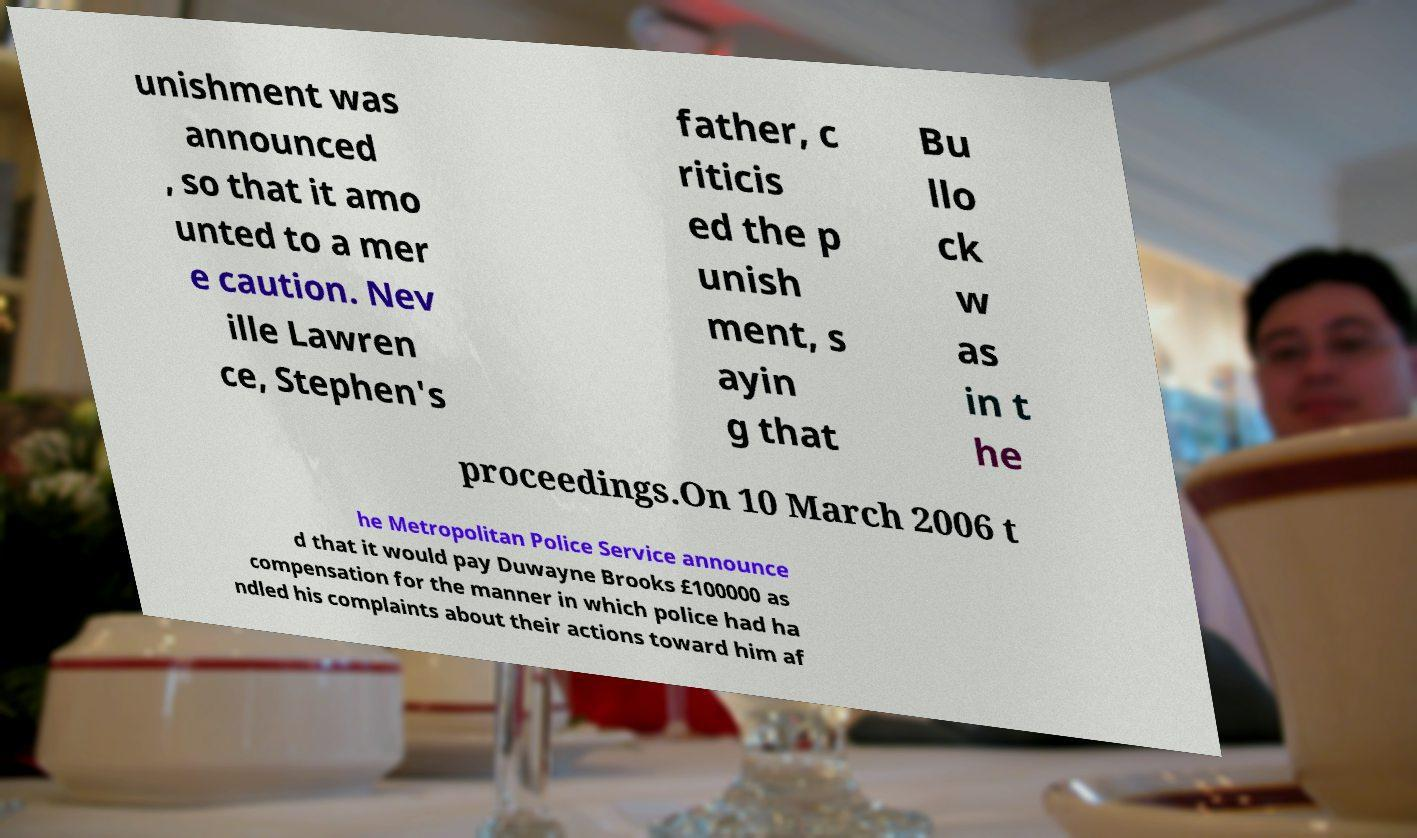For documentation purposes, I need the text within this image transcribed. Could you provide that? unishment was announced , so that it amo unted to a mer e caution. Nev ille Lawren ce, Stephen's father, c riticis ed the p unish ment, s ayin g that Bu llo ck w as in t he proceedings.On 10 March 2006 t he Metropolitan Police Service announce d that it would pay Duwayne Brooks £100000 as compensation for the manner in which police had ha ndled his complaints about their actions toward him af 